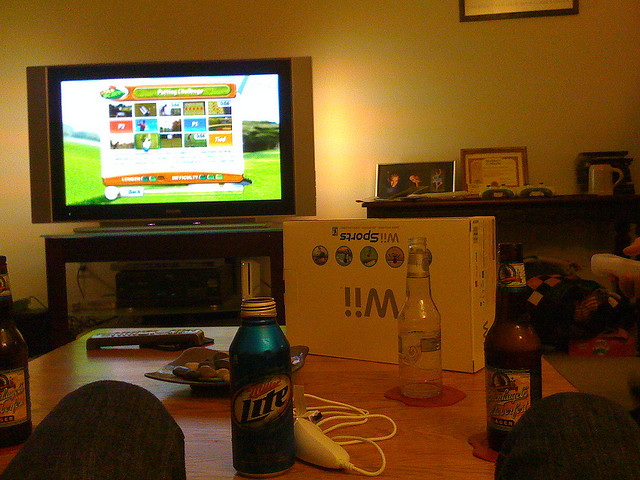Read and extract the text from this image. Wii WiiSports 